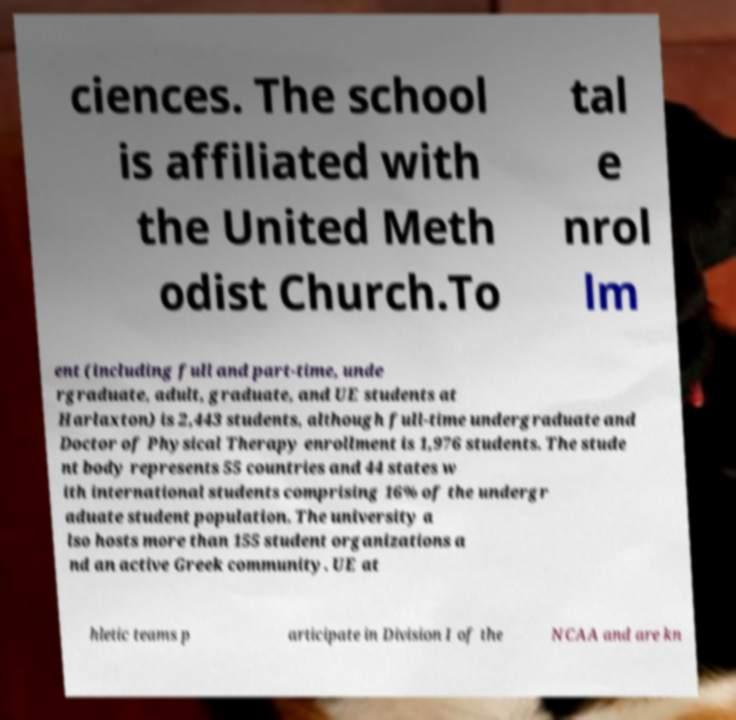Can you accurately transcribe the text from the provided image for me? ciences. The school is affiliated with the United Meth odist Church.To tal e nrol lm ent (including full and part-time, unde rgraduate, adult, graduate, and UE students at Harlaxton) is 2,443 students, although full-time undergraduate and Doctor of Physical Therapy enrollment is 1,976 students. The stude nt body represents 55 countries and 44 states w ith international students comprising 16% of the undergr aduate student population. The university a lso hosts more than 155 student organizations a nd an active Greek community. UE at hletic teams p articipate in Division I of the NCAA and are kn 